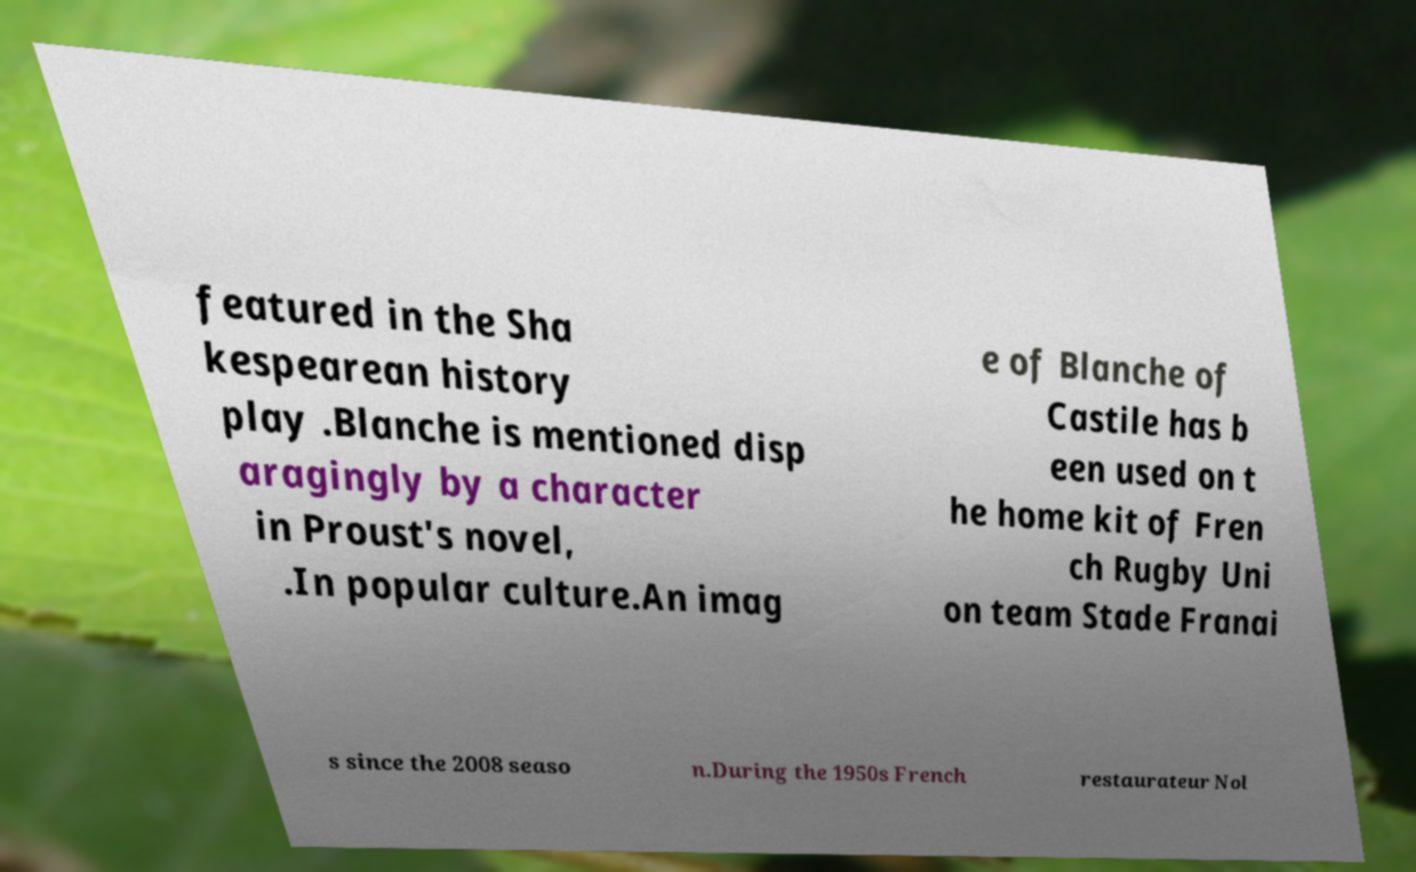There's text embedded in this image that I need extracted. Can you transcribe it verbatim? featured in the Sha kespearean history play .Blanche is mentioned disp aragingly by a character in Proust's novel, .In popular culture.An imag e of Blanche of Castile has b een used on t he home kit of Fren ch Rugby Uni on team Stade Franai s since the 2008 seaso n.During the 1950s French restaurateur Nol 